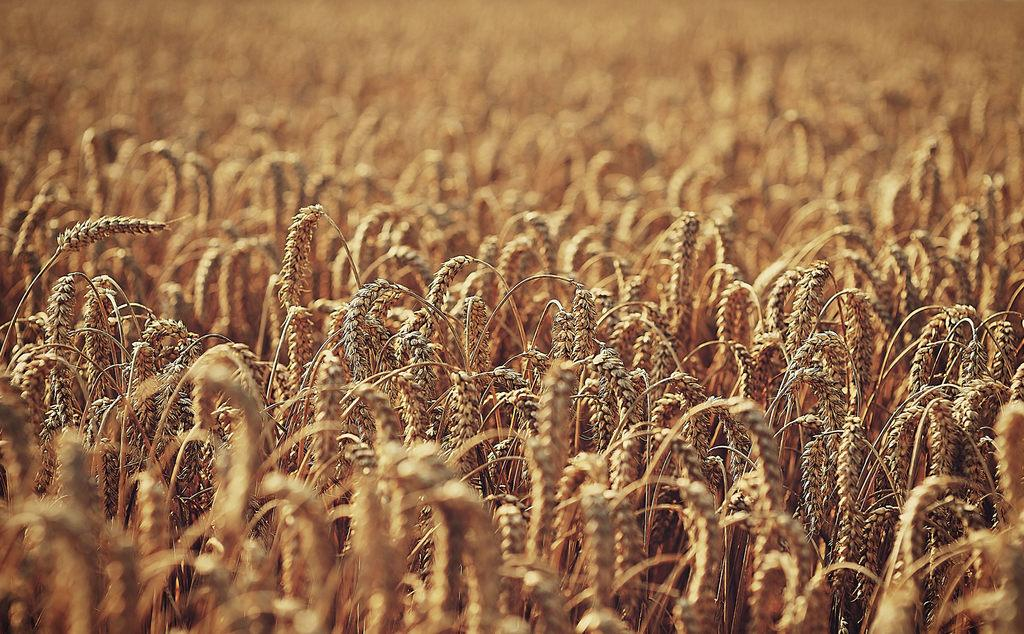What type of landscape is depicted in the image? There is a field in the image. Can you describe the terrain in the image? The terrain in the image consists of a field. What might be growing or present in the field? It is not specified what might be growing or present in the field. What type of engine can be seen powering the fold in the image? There is no engine or fold present in the image; it only depicts a field. 